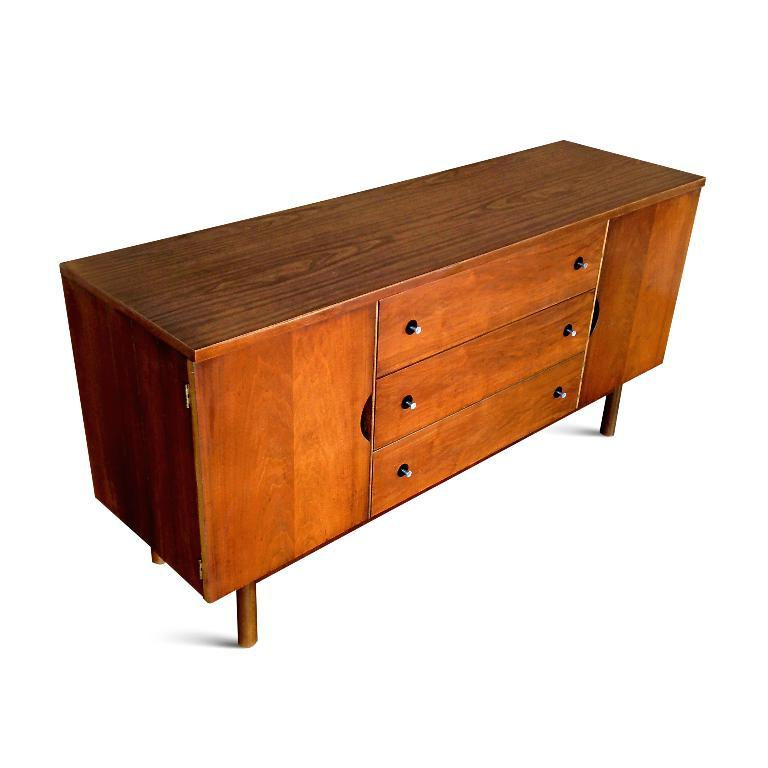What type of table is in the image? There is a wooden table in the image. What feature does the wooden table have? The wooden table has three drawers. How does the beginner play the drum in the image? There is no drum or beginner present in the image; it only features a wooden table with three drawers. 